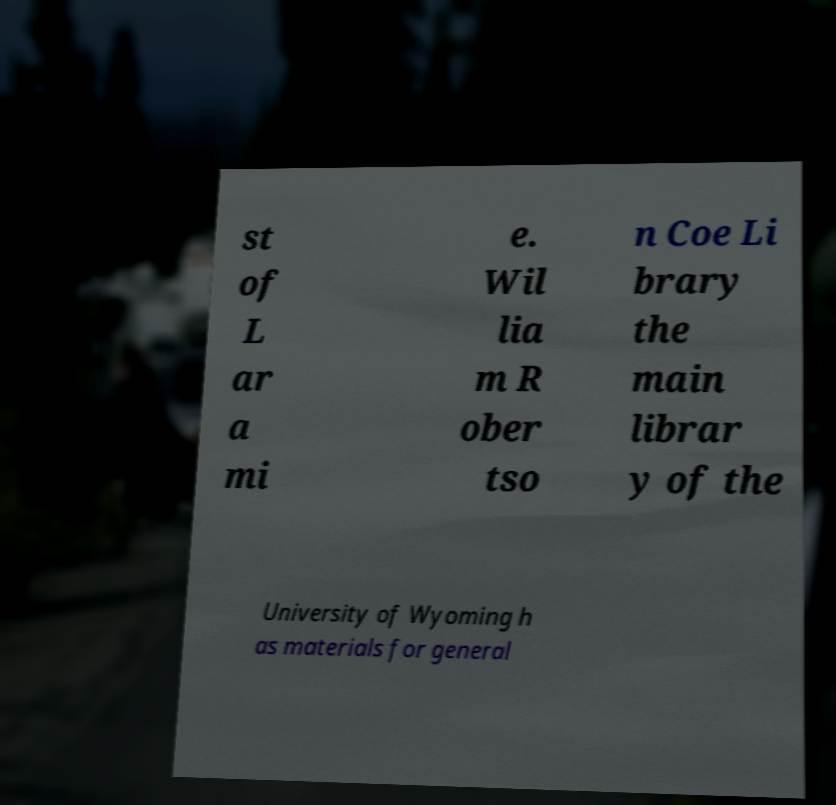I need the written content from this picture converted into text. Can you do that? st of L ar a mi e. Wil lia m R ober tso n Coe Li brary the main librar y of the University of Wyoming h as materials for general 